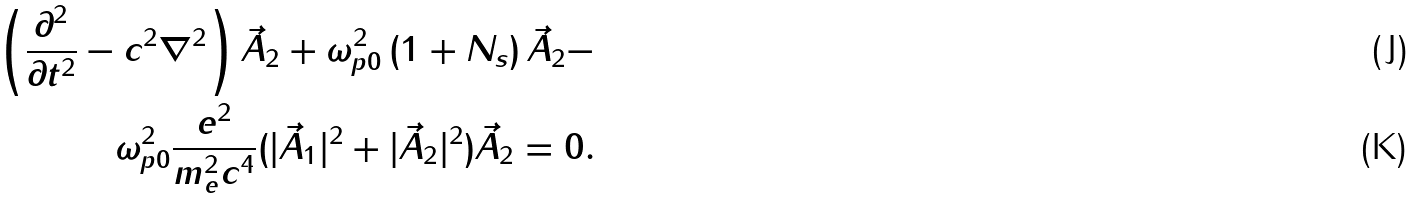Convert formula to latex. <formula><loc_0><loc_0><loc_500><loc_500>\left ( \frac { \partial ^ { 2 } } { \partial t ^ { 2 } } - c ^ { 2 } \nabla ^ { 2 } \right ) \vec { A } _ { 2 } + \omega _ { p 0 } ^ { 2 } \left ( 1 + N _ { s } \right ) \vec { A } _ { 2 } - \\ \omega _ { p 0 } ^ { 2 } \frac { e ^ { 2 } } { m _ { e } ^ { 2 } c ^ { 4 } } ( | \vec { A } _ { 1 } | ^ { 2 } + | \vec { A } _ { 2 } | ^ { 2 } ) \vec { A } _ { 2 } = 0 .</formula> 